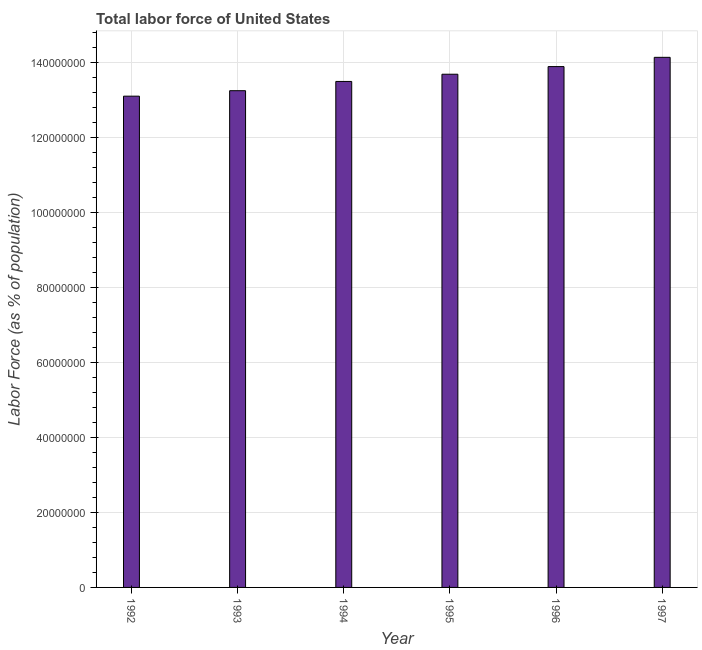Does the graph contain any zero values?
Offer a very short reply. No. Does the graph contain grids?
Give a very brief answer. Yes. What is the title of the graph?
Your answer should be very brief. Total labor force of United States. What is the label or title of the X-axis?
Offer a very short reply. Year. What is the label or title of the Y-axis?
Offer a very short reply. Labor Force (as % of population). What is the total labor force in 1993?
Ensure brevity in your answer.  1.33e+08. Across all years, what is the maximum total labor force?
Provide a short and direct response. 1.41e+08. Across all years, what is the minimum total labor force?
Make the answer very short. 1.31e+08. What is the sum of the total labor force?
Give a very brief answer. 8.16e+08. What is the difference between the total labor force in 1995 and 1996?
Keep it short and to the point. -2.04e+06. What is the average total labor force per year?
Ensure brevity in your answer.  1.36e+08. What is the median total labor force?
Keep it short and to the point. 1.36e+08. In how many years, is the total labor force greater than 112000000 %?
Keep it short and to the point. 6. What is the ratio of the total labor force in 1994 to that in 1997?
Your answer should be compact. 0.95. Is the total labor force in 1996 less than that in 1997?
Offer a very short reply. Yes. Is the difference between the total labor force in 1994 and 1995 greater than the difference between any two years?
Ensure brevity in your answer.  No. What is the difference between the highest and the second highest total labor force?
Your answer should be very brief. 2.47e+06. What is the difference between the highest and the lowest total labor force?
Your answer should be compact. 1.04e+07. In how many years, is the total labor force greater than the average total labor force taken over all years?
Ensure brevity in your answer.  3. How many bars are there?
Your response must be concise. 6. Are all the bars in the graph horizontal?
Your answer should be compact. No. How many years are there in the graph?
Make the answer very short. 6. What is the difference between two consecutive major ticks on the Y-axis?
Ensure brevity in your answer.  2.00e+07. What is the Labor Force (as % of population) in 1992?
Offer a very short reply. 1.31e+08. What is the Labor Force (as % of population) of 1993?
Give a very brief answer. 1.33e+08. What is the Labor Force (as % of population) of 1994?
Give a very brief answer. 1.35e+08. What is the Labor Force (as % of population) in 1995?
Your answer should be compact. 1.37e+08. What is the Labor Force (as % of population) of 1996?
Keep it short and to the point. 1.39e+08. What is the Labor Force (as % of population) in 1997?
Your response must be concise. 1.41e+08. What is the difference between the Labor Force (as % of population) in 1992 and 1993?
Your answer should be compact. -1.46e+06. What is the difference between the Labor Force (as % of population) in 1992 and 1994?
Your response must be concise. -3.93e+06. What is the difference between the Labor Force (as % of population) in 1992 and 1995?
Your response must be concise. -5.85e+06. What is the difference between the Labor Force (as % of population) in 1992 and 1996?
Provide a short and direct response. -7.89e+06. What is the difference between the Labor Force (as % of population) in 1992 and 1997?
Your answer should be compact. -1.04e+07. What is the difference between the Labor Force (as % of population) in 1993 and 1994?
Your answer should be compact. -2.47e+06. What is the difference between the Labor Force (as % of population) in 1993 and 1995?
Give a very brief answer. -4.39e+06. What is the difference between the Labor Force (as % of population) in 1993 and 1996?
Provide a succinct answer. -6.43e+06. What is the difference between the Labor Force (as % of population) in 1993 and 1997?
Make the answer very short. -8.90e+06. What is the difference between the Labor Force (as % of population) in 1994 and 1995?
Provide a short and direct response. -1.92e+06. What is the difference between the Labor Force (as % of population) in 1994 and 1996?
Provide a succinct answer. -3.96e+06. What is the difference between the Labor Force (as % of population) in 1994 and 1997?
Provide a succinct answer. -6.43e+06. What is the difference between the Labor Force (as % of population) in 1995 and 1996?
Offer a terse response. -2.04e+06. What is the difference between the Labor Force (as % of population) in 1995 and 1997?
Offer a very short reply. -4.51e+06. What is the difference between the Labor Force (as % of population) in 1996 and 1997?
Give a very brief answer. -2.47e+06. What is the ratio of the Labor Force (as % of population) in 1992 to that in 1993?
Make the answer very short. 0.99. What is the ratio of the Labor Force (as % of population) in 1992 to that in 1994?
Your answer should be compact. 0.97. What is the ratio of the Labor Force (as % of population) in 1992 to that in 1996?
Keep it short and to the point. 0.94. What is the ratio of the Labor Force (as % of population) in 1992 to that in 1997?
Provide a succinct answer. 0.93. What is the ratio of the Labor Force (as % of population) in 1993 to that in 1995?
Keep it short and to the point. 0.97. What is the ratio of the Labor Force (as % of population) in 1993 to that in 1996?
Your answer should be very brief. 0.95. What is the ratio of the Labor Force (as % of population) in 1993 to that in 1997?
Give a very brief answer. 0.94. What is the ratio of the Labor Force (as % of population) in 1994 to that in 1995?
Offer a very short reply. 0.99. What is the ratio of the Labor Force (as % of population) in 1994 to that in 1997?
Make the answer very short. 0.95. What is the ratio of the Labor Force (as % of population) in 1995 to that in 1996?
Keep it short and to the point. 0.98. What is the ratio of the Labor Force (as % of population) in 1995 to that in 1997?
Make the answer very short. 0.97. 